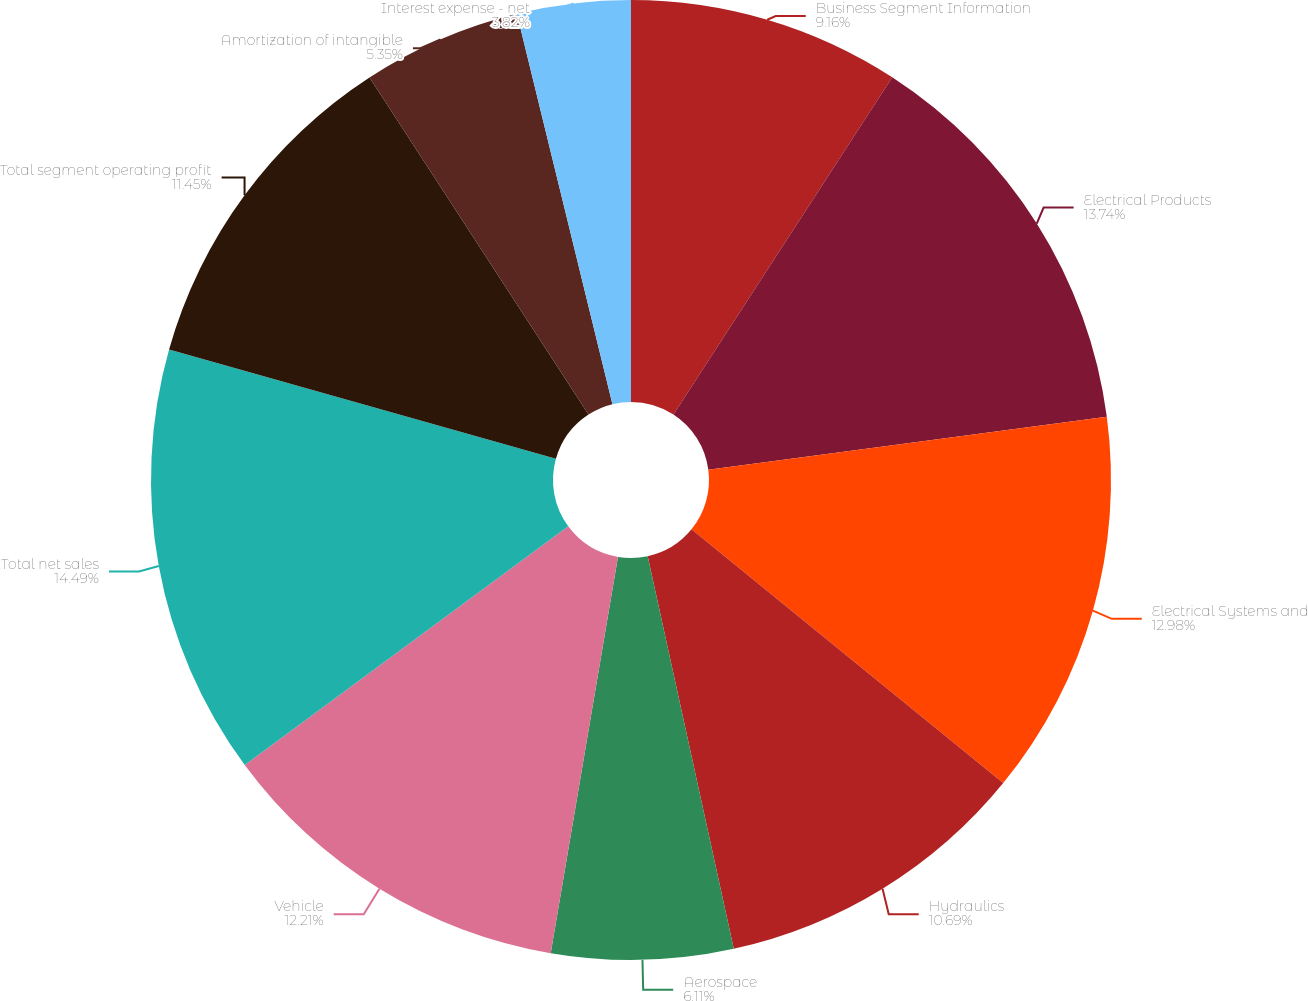Convert chart. <chart><loc_0><loc_0><loc_500><loc_500><pie_chart><fcel>Business Segment Information<fcel>Electrical Products<fcel>Electrical Systems and<fcel>Hydraulics<fcel>Aerospace<fcel>Vehicle<fcel>Total net sales<fcel>Total segment operating profit<fcel>Amortization of intangible<fcel>Interest expense - net<nl><fcel>9.16%<fcel>13.74%<fcel>12.98%<fcel>10.69%<fcel>6.11%<fcel>12.21%<fcel>14.5%<fcel>11.45%<fcel>5.35%<fcel>3.82%<nl></chart> 